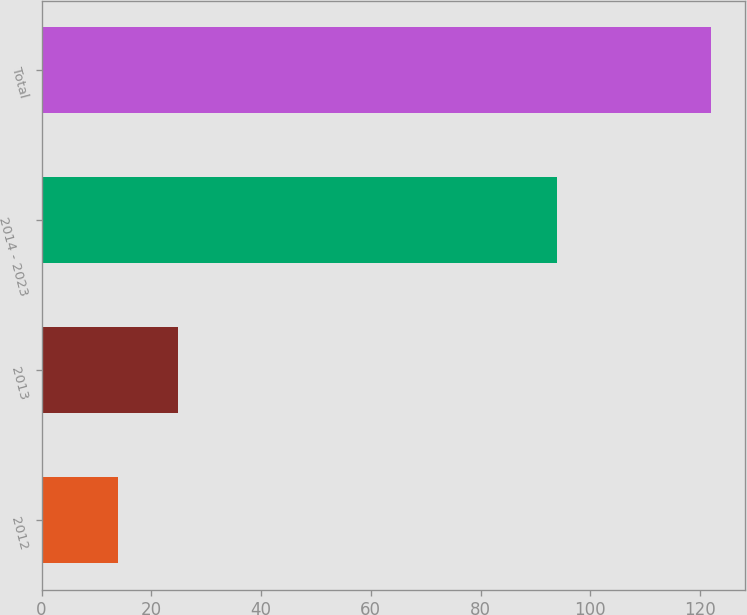Convert chart to OTSL. <chart><loc_0><loc_0><loc_500><loc_500><bar_chart><fcel>2012<fcel>2013<fcel>2014 - 2023<fcel>Total<nl><fcel>14<fcel>24.8<fcel>94<fcel>122<nl></chart> 